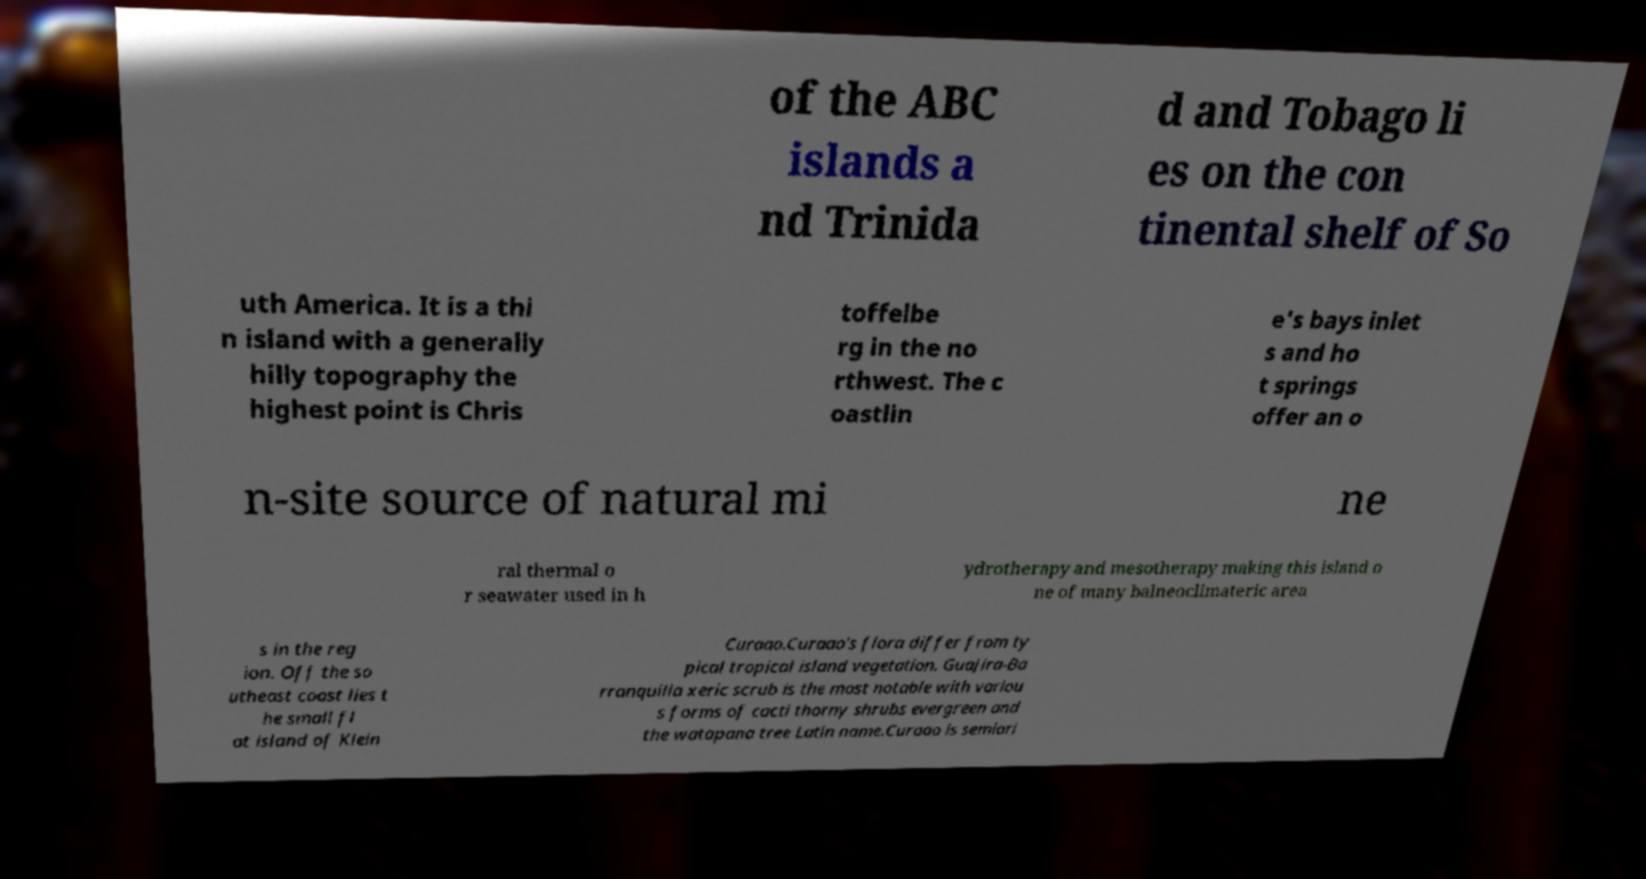Please read and relay the text visible in this image. What does it say? of the ABC islands a nd Trinida d and Tobago li es on the con tinental shelf of So uth America. It is a thi n island with a generally hilly topography the highest point is Chris toffelbe rg in the no rthwest. The c oastlin e's bays inlet s and ho t springs offer an o n-site source of natural mi ne ral thermal o r seawater used in h ydrotherapy and mesotherapy making this island o ne of many balneoclimateric area s in the reg ion. Off the so utheast coast lies t he small fl at island of Klein Curaao.Curaao's flora differ from ty pical tropical island vegetation. Guajira-Ba rranquilla xeric scrub is the most notable with variou s forms of cacti thorny shrubs evergreen and the watapana tree Latin name.Curaao is semiari 